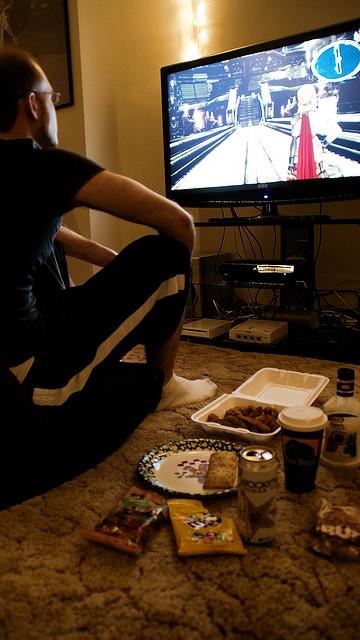Is the TV turned on?
Concise answer only. Yes. Is it possible that this person has the munchies?
Write a very short answer. Yes. What game system?
Short answer required. Wii. What color is the carpet?
Keep it brief. Brown. What is the man doing?
Be succinct. Watching tv. What is on the screen?
Keep it brief. Game. 